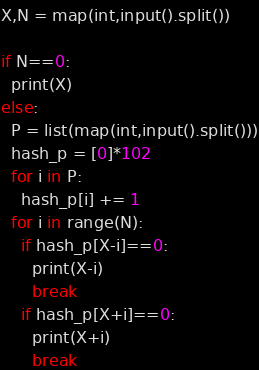Convert code to text. <code><loc_0><loc_0><loc_500><loc_500><_Python_>X,N = map(int,input().split())

if N==0:
  print(X)
else:
  P = list(map(int,input().split()))
  hash_p = [0]*102
  for i in P:
    hash_p[i] += 1
  for i in range(N):
    if hash_p[X-i]==0:
      print(X-i)
      break
    if hash_p[X+i]==0:
      print(X+i)
      break</code> 